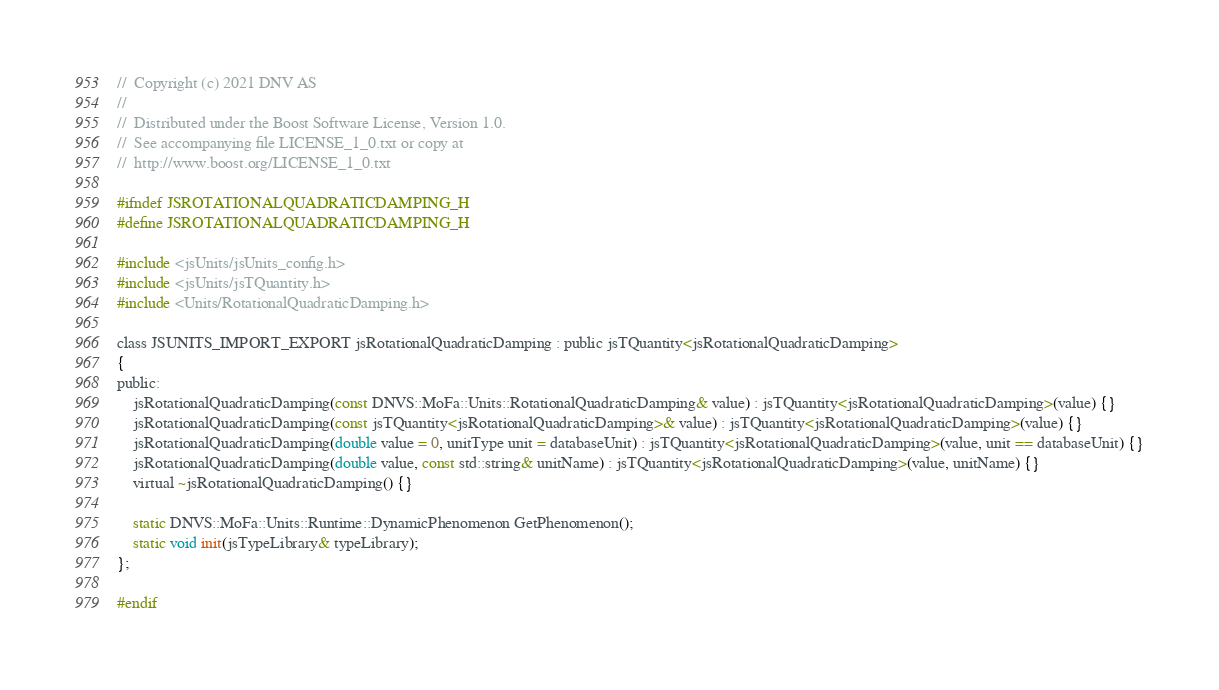<code> <loc_0><loc_0><loc_500><loc_500><_C_>//  Copyright (c) 2021 DNV AS
//
//  Distributed under the Boost Software License, Version 1.0.
//  See accompanying file LICENSE_1_0.txt or copy at
//  http://www.boost.org/LICENSE_1_0.txt

#ifndef JSROTATIONALQUADRATICDAMPING_H
#define JSROTATIONALQUADRATICDAMPING_H

#include <jsUnits/jsUnits_config.h>
#include <jsUnits/jsTQuantity.h>
#include <Units/RotationalQuadraticDamping.h>

class JSUNITS_IMPORT_EXPORT jsRotationalQuadraticDamping : public jsTQuantity<jsRotationalQuadraticDamping>
{
public:
    jsRotationalQuadraticDamping(const DNVS::MoFa::Units::RotationalQuadraticDamping& value) : jsTQuantity<jsRotationalQuadraticDamping>(value) {}
    jsRotationalQuadraticDamping(const jsTQuantity<jsRotationalQuadraticDamping>& value) : jsTQuantity<jsRotationalQuadraticDamping>(value) {}
    jsRotationalQuadraticDamping(double value = 0, unitType unit = databaseUnit) : jsTQuantity<jsRotationalQuadraticDamping>(value, unit == databaseUnit) {}
    jsRotationalQuadraticDamping(double value, const std::string& unitName) : jsTQuantity<jsRotationalQuadraticDamping>(value, unitName) {}
    virtual ~jsRotationalQuadraticDamping() {}

    static DNVS::MoFa::Units::Runtime::DynamicPhenomenon GetPhenomenon();
    static void init(jsTypeLibrary& typeLibrary);
};

#endif 
</code> 